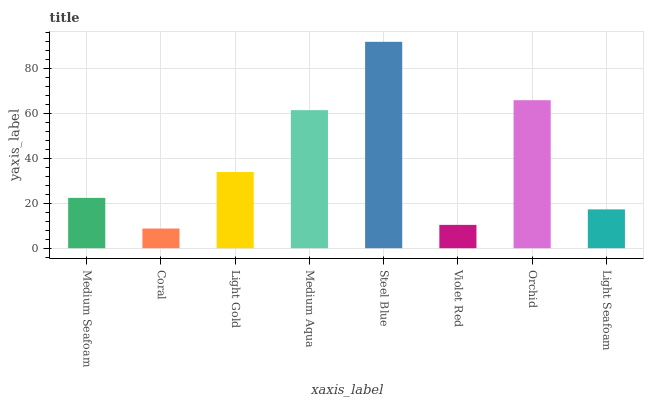Is Coral the minimum?
Answer yes or no. Yes. Is Steel Blue the maximum?
Answer yes or no. Yes. Is Light Gold the minimum?
Answer yes or no. No. Is Light Gold the maximum?
Answer yes or no. No. Is Light Gold greater than Coral?
Answer yes or no. Yes. Is Coral less than Light Gold?
Answer yes or no. Yes. Is Coral greater than Light Gold?
Answer yes or no. No. Is Light Gold less than Coral?
Answer yes or no. No. Is Light Gold the high median?
Answer yes or no. Yes. Is Medium Seafoam the low median?
Answer yes or no. Yes. Is Coral the high median?
Answer yes or no. No. Is Orchid the low median?
Answer yes or no. No. 